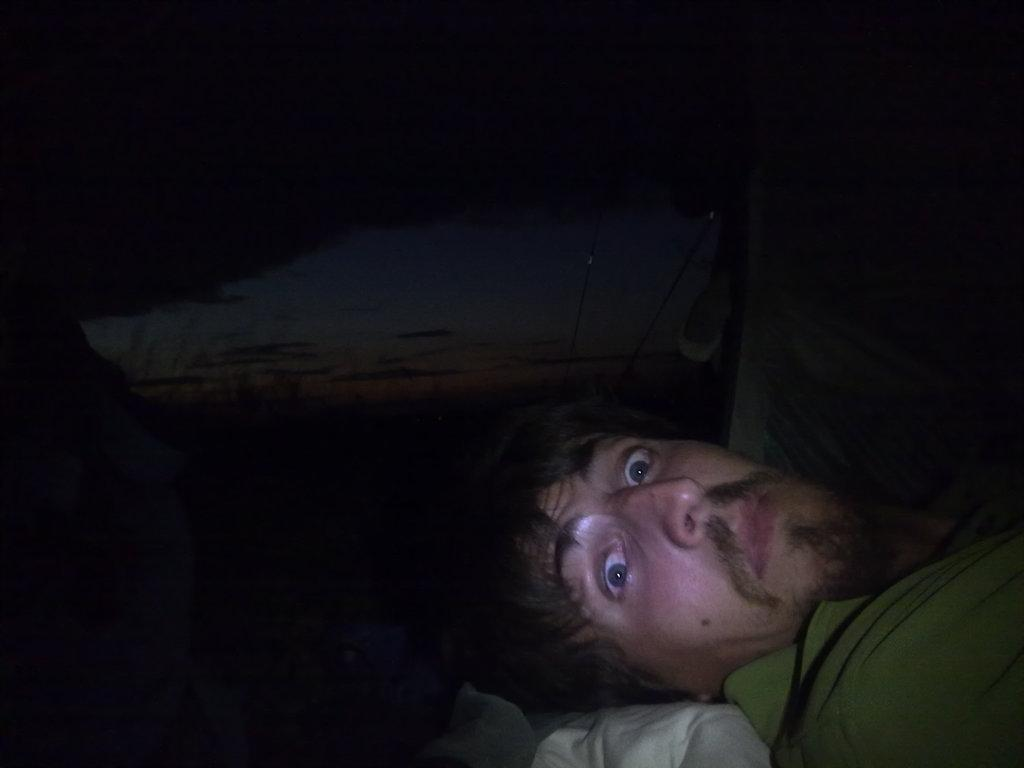What is the man in the image doing? The man is lying down in the image. What is supporting the man's head? There is a cloth below the man's head. What can be seen in the center of the image? The sky is visible in the center of the image. How would you describe the lighting in the image? The image is dark. What type of shoes is the man wearing in the image? There is no mention of shoes in the image, so we cannot determine what type of shoes the man is wearing. 